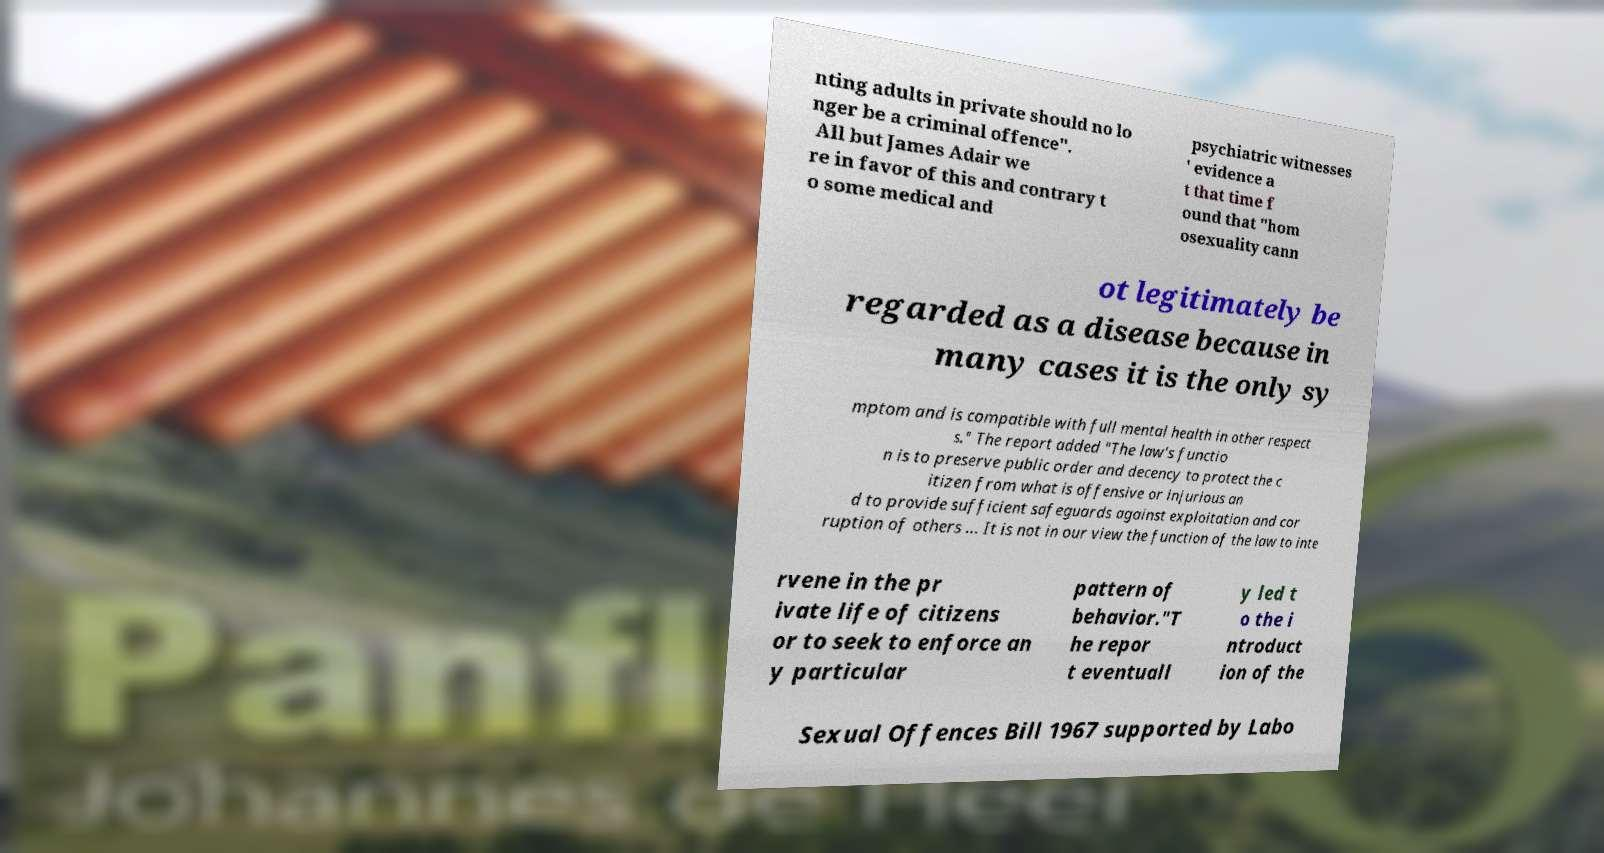There's text embedded in this image that I need extracted. Can you transcribe it verbatim? nting adults in private should no lo nger be a criminal offence". All but James Adair we re in favor of this and contrary t o some medical and psychiatric witnesses ' evidence a t that time f ound that "hom osexuality cann ot legitimately be regarded as a disease because in many cases it is the only sy mptom and is compatible with full mental health in other respect s." The report added "The law's functio n is to preserve public order and decency to protect the c itizen from what is offensive or injurious an d to provide sufficient safeguards against exploitation and cor ruption of others … It is not in our view the function of the law to inte rvene in the pr ivate life of citizens or to seek to enforce an y particular pattern of behavior."T he repor t eventuall y led t o the i ntroduct ion of the Sexual Offences Bill 1967 supported by Labo 